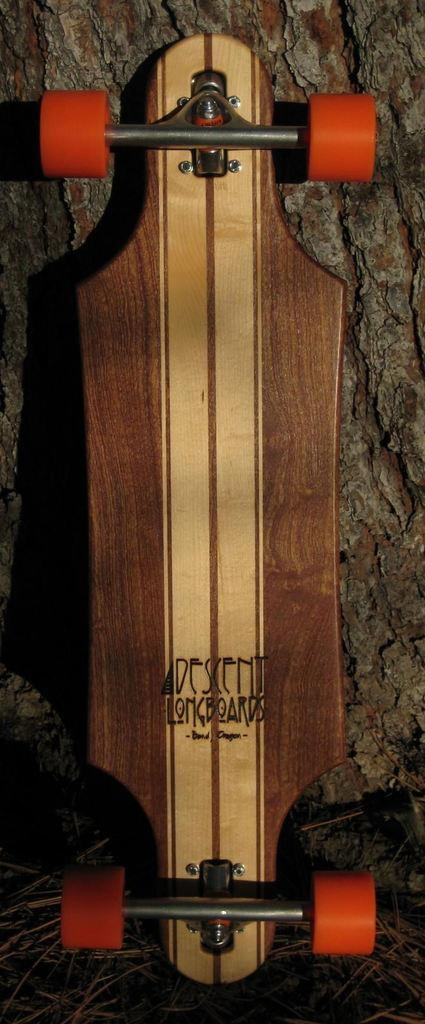What object is the main focus of the image? There is a skateboard in the image. Can you describe the background of the image? There is a tree trunk visible in the background of the image. What is the skateboard's suggestion for a chance to catch a net in the image? There is no suggestion, chance, or net present in the image; it only features a skateboard and a tree trunk in the background. 